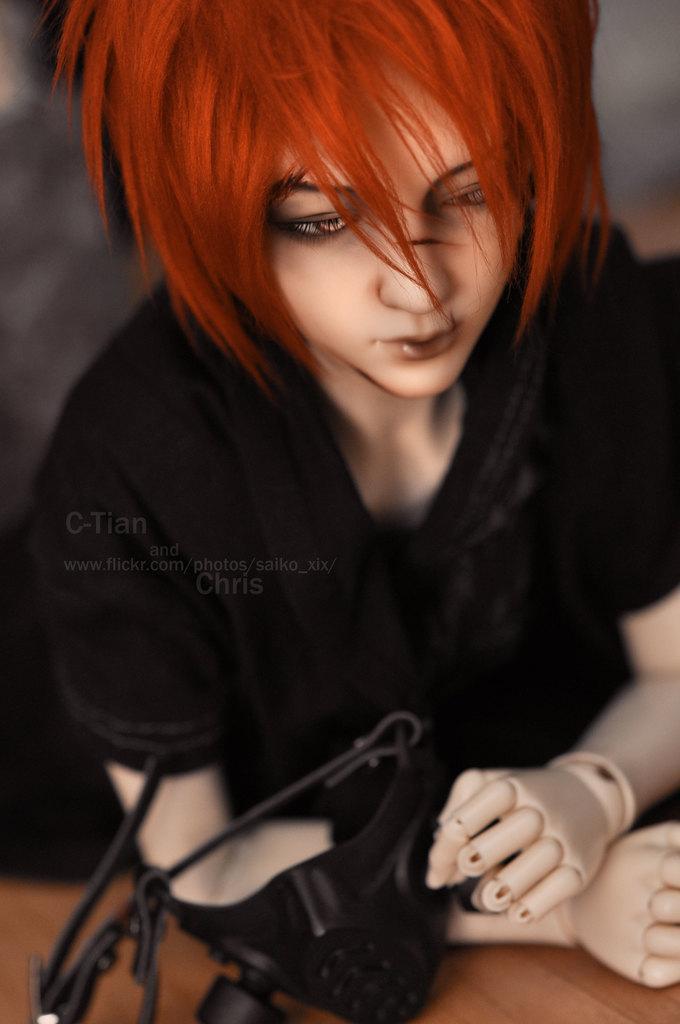Please provide a concise description of this image. In this image, we can see a human toy in black dress is holding a mask. At the bottom, we can see wooden object. Background there is a blur view. 